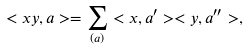<formula> <loc_0><loc_0><loc_500><loc_500>< x y , a > = \sum _ { ( a ) } < x , a ^ { \prime } > < y , a ^ { \prime \prime } > ,</formula> 